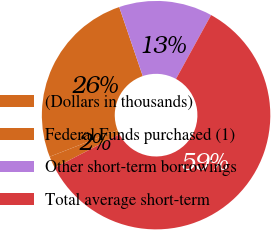Convert chart. <chart><loc_0><loc_0><loc_500><loc_500><pie_chart><fcel>(Dollars in thousands)<fcel>Federal Funds purchased (1)<fcel>Other short-term borrowings<fcel>Total average short-term<nl><fcel>1.69%<fcel>25.7%<fcel>13.23%<fcel>59.39%<nl></chart> 